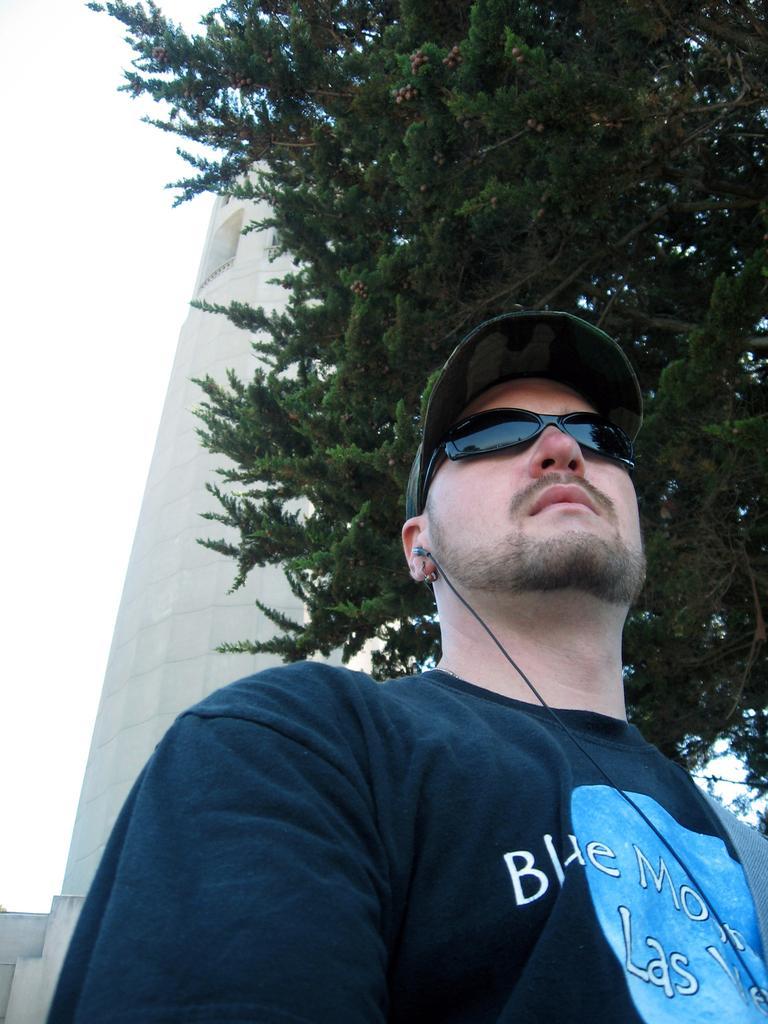In one or two sentences, can you explain what this image depicts? In this image I can see a man and I can see he is wearing black colour t shirt, black shades, a cap and here I can see something is written. I can also see an earphone, a tree and a building in the background. 